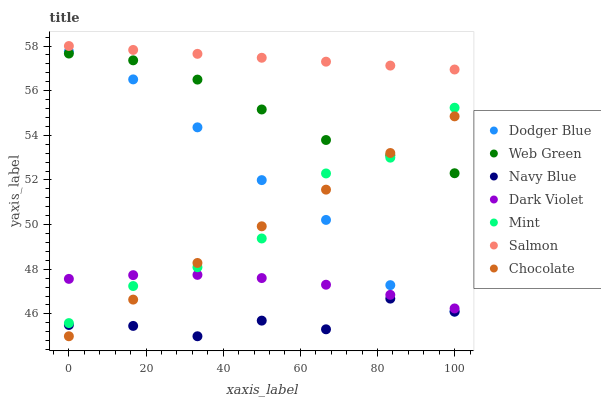Does Navy Blue have the minimum area under the curve?
Answer yes or no. Yes. Does Salmon have the maximum area under the curve?
Answer yes or no. Yes. Does Dark Violet have the minimum area under the curve?
Answer yes or no. No. Does Dark Violet have the maximum area under the curve?
Answer yes or no. No. Is Chocolate the smoothest?
Answer yes or no. Yes. Is Mint the roughest?
Answer yes or no. Yes. Is Salmon the smoothest?
Answer yes or no. No. Is Salmon the roughest?
Answer yes or no. No. Does Navy Blue have the lowest value?
Answer yes or no. Yes. Does Dark Violet have the lowest value?
Answer yes or no. No. Does Salmon have the highest value?
Answer yes or no. Yes. Does Dark Violet have the highest value?
Answer yes or no. No. Is Dark Violet less than Web Green?
Answer yes or no. Yes. Is Web Green greater than Dark Violet?
Answer yes or no. Yes. Does Dark Violet intersect Dodger Blue?
Answer yes or no. Yes. Is Dark Violet less than Dodger Blue?
Answer yes or no. No. Is Dark Violet greater than Dodger Blue?
Answer yes or no. No. Does Dark Violet intersect Web Green?
Answer yes or no. No. 